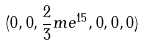Convert formula to latex. <formula><loc_0><loc_0><loc_500><loc_500>( 0 , 0 , \frac { 2 } { 3 } m e ^ { 1 5 } , 0 , 0 , 0 )</formula> 